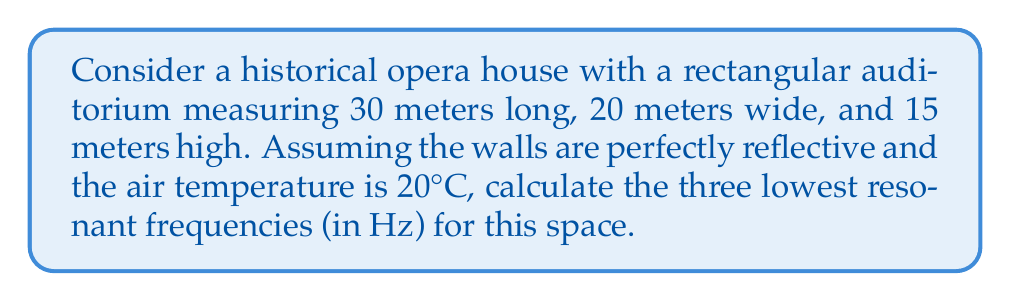Solve this math problem. To calculate the resonant frequencies of a rectangular room, we use the following steps:

1. The formula for resonant frequencies in a rectangular room is:

   $$f_{nml} = \frac{c}{2} \sqrt{\left(\frac{n}{L_x}\right)^2 + \left(\frac{m}{L_y}\right)^2 + \left(\frac{l}{L_z}\right)^2}$$

   Where:
   - $f_{nml}$ is the resonant frequency
   - $c$ is the speed of sound in air
   - $L_x$, $L_y$, and $L_z$ are the room dimensions
   - $n$, $m$, and $l$ are non-negative integers (at least one must be non-zero)

2. Calculate the speed of sound at 20°C:
   $$c = 331.3 + 0.606T$$
   $$c = 331.3 + 0.606(20) = 343.42 \text{ m/s}$$

3. Use the given dimensions:
   $L_x = 30 \text{ m}$, $L_y = 20 \text{ m}$, $L_z = 15 \text{ m}$

4. Calculate the three lowest frequencies:

   a) $f_{100}$ (1,0,0 mode):
      $$f_{100} = \frac{343.42}{2} \sqrt{\left(\frac{1}{30}\right)^2 + 0^2 + 0^2} = 5.72 \text{ Hz}$$

   b) $f_{010}$ (0,1,0 mode):
      $$f_{010} = \frac{343.42}{2} \sqrt{0^2 + \left(\frac{1}{20}\right)^2 + 0^2} = 8.59 \text{ Hz}$$

   c) $f_{001}$ (0,0,1 mode):
      $$f_{001} = \frac{343.42}{2} \sqrt{0^2 + 0^2 + \left(\frac{1}{15}\right)^2} = 11.45 \text{ Hz}$$
Answer: 5.72 Hz, 8.59 Hz, 11.45 Hz 